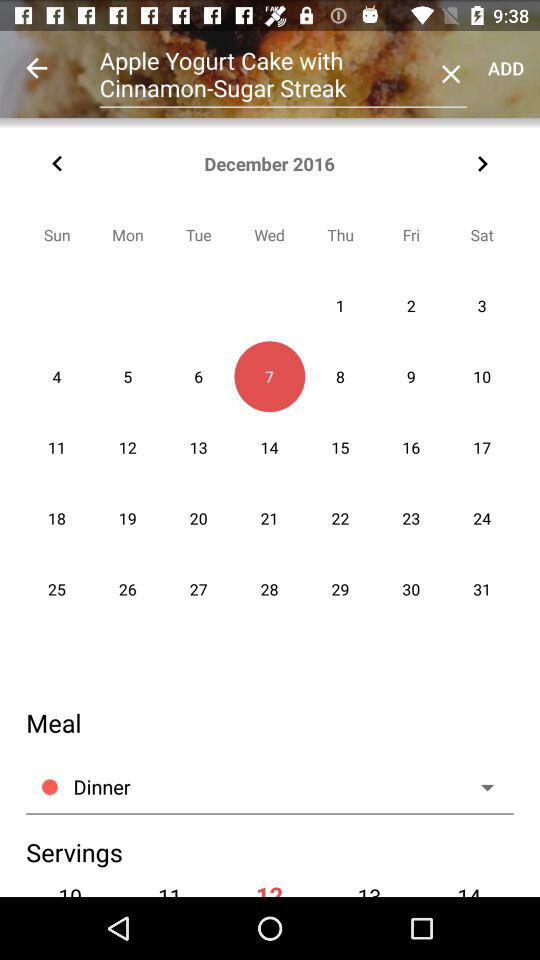What option is selected in the meal? The selected option is dinner. 